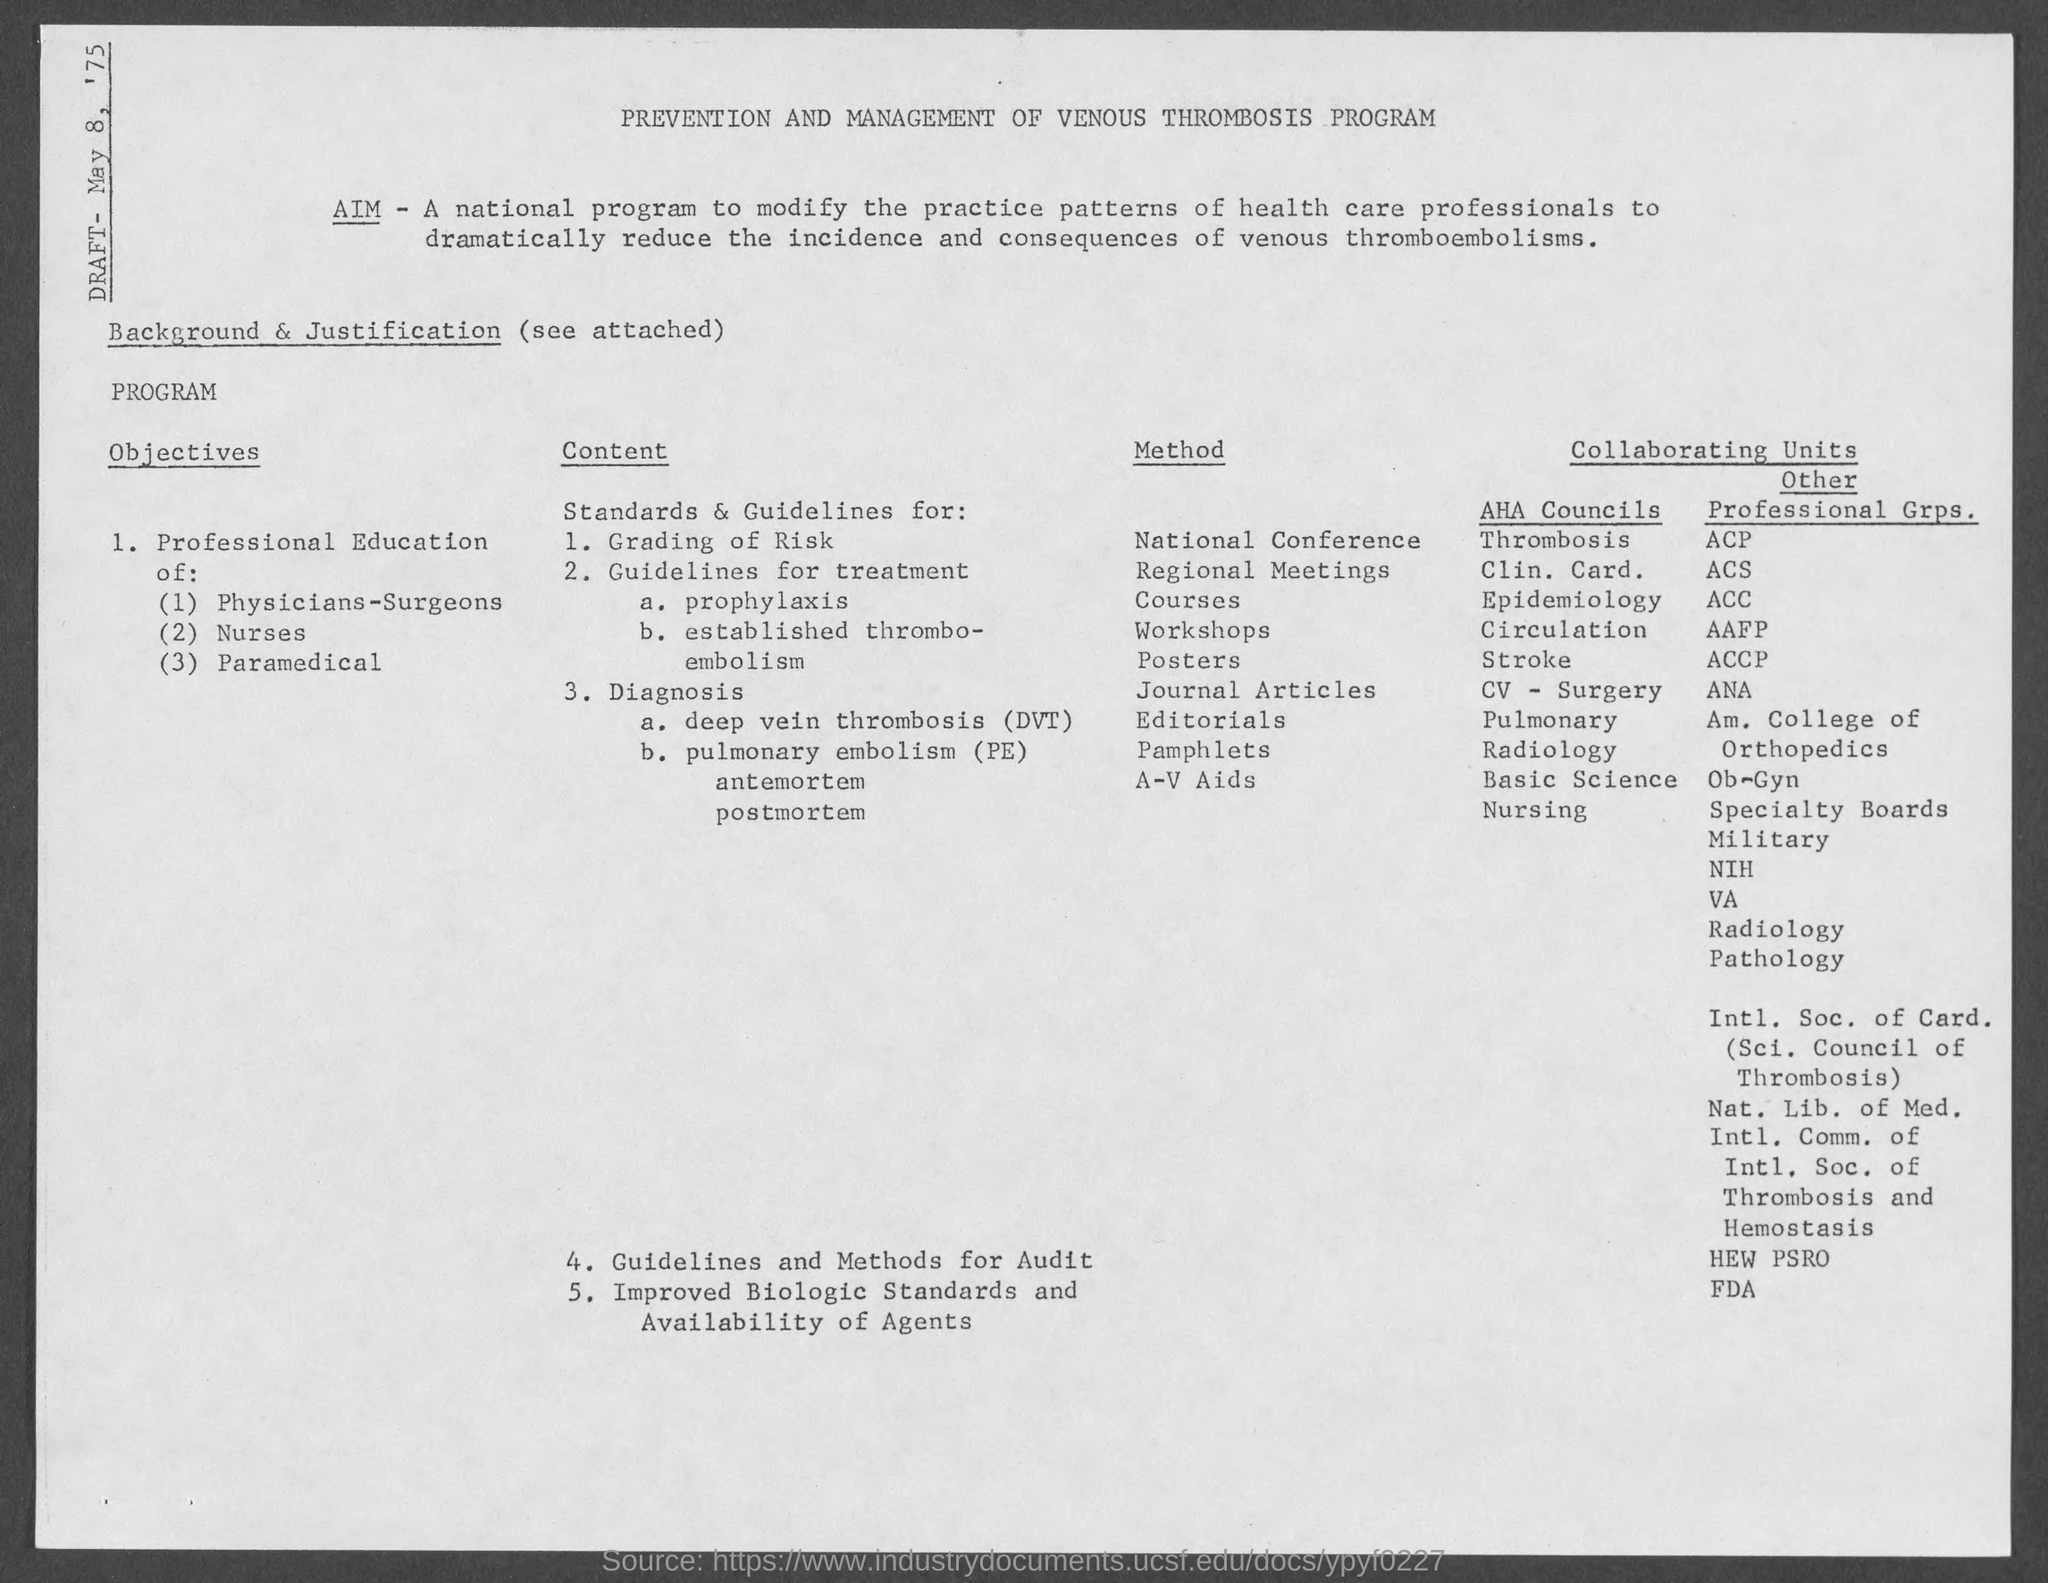What is the date of the draft?
Your answer should be very brief. May 8, '75. What is the heading of the document ?
Give a very brief answer. PREVENTION AND MANAGEMENT OF VENOUS THROMBOSIS PROGRAM. What is the first method used?
Offer a terse response. National conference. What is the first content?
Keep it short and to the point. Grading of Risk. 